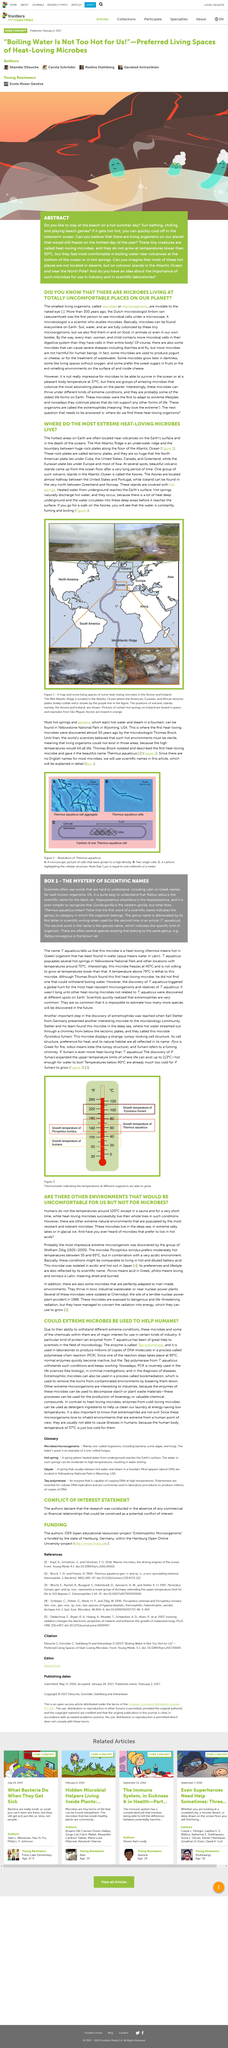Give some essential details in this illustration. Microorganisms are usually not harmful to humans because the human body temperature of 37 degrees Celsius is too cold for them to survive and cause illness. It is clear that extremophiles are widely present in our planet, and it is expected that many more species will be discovered in the future. Taq-polymerase is an enzyme that is commonly used in laboratories to produce DNA molecules by copying the DNA molecules. The countries located on top of the American tectonic plate are Cuba, the United States, Canada, and Greenland. The use of extreme microbes in certain industries is beneficial to humans because they possess the unique ability to thrive in extreme conditions. 